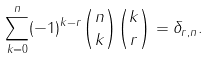<formula> <loc_0><loc_0><loc_500><loc_500>\sum _ { k = 0 } ^ { n } ( - 1 ) ^ { k - r } { n \choose k } { k \choose r } = \delta _ { r , n } .</formula> 